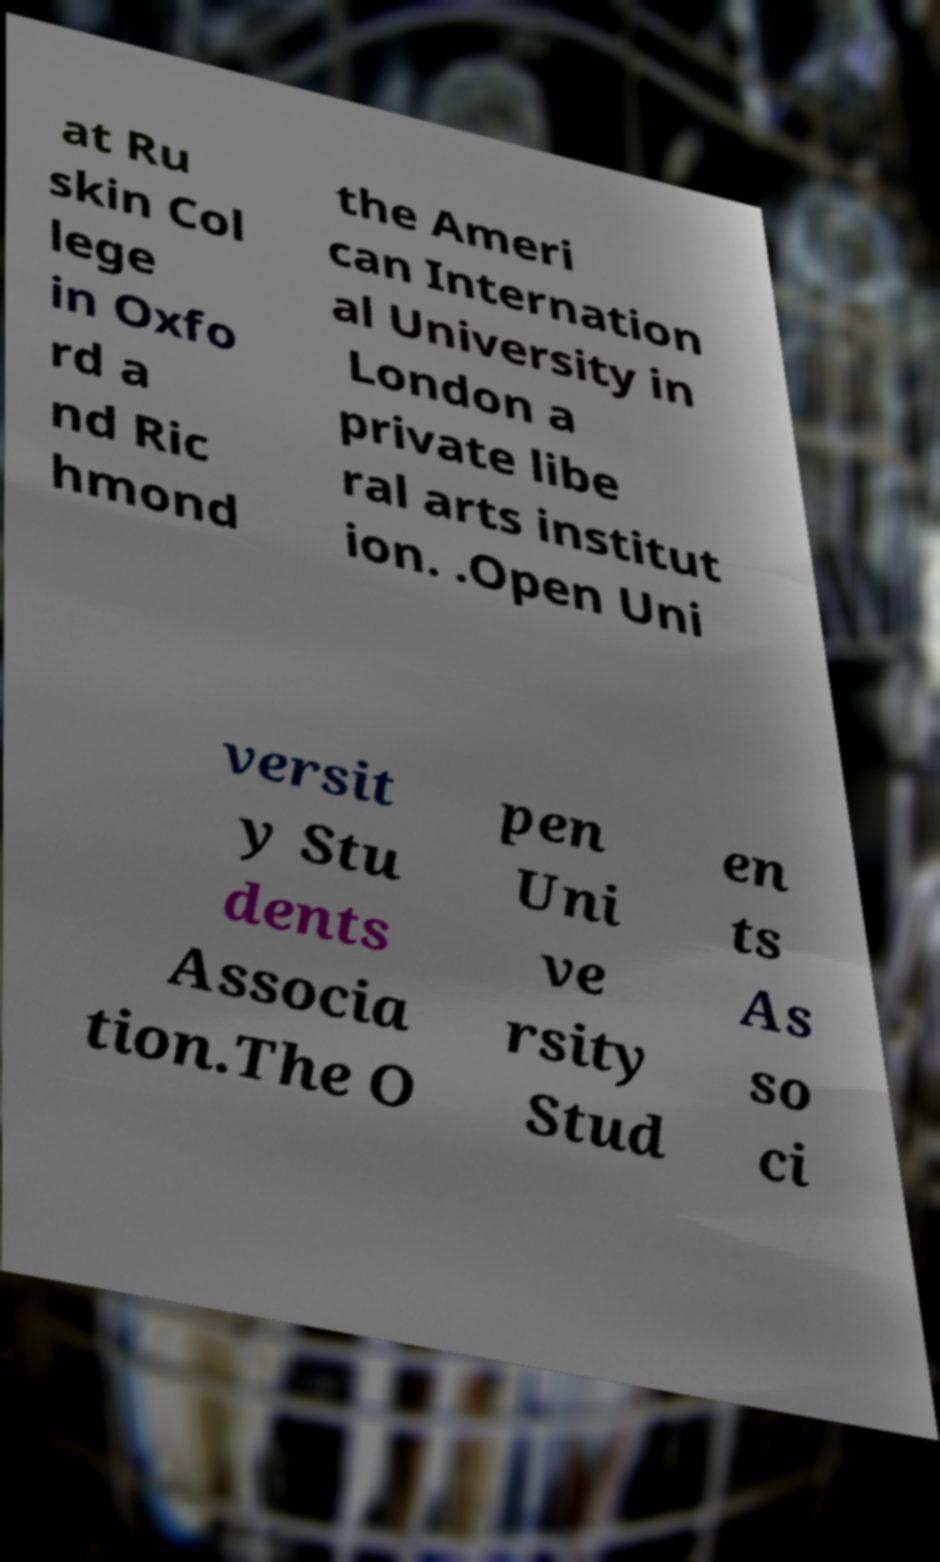Could you assist in decoding the text presented in this image and type it out clearly? at Ru skin Col lege in Oxfo rd a nd Ric hmond the Ameri can Internation al University in London a private libe ral arts institut ion. .Open Uni versit y Stu dents Associa tion.The O pen Uni ve rsity Stud en ts As so ci 